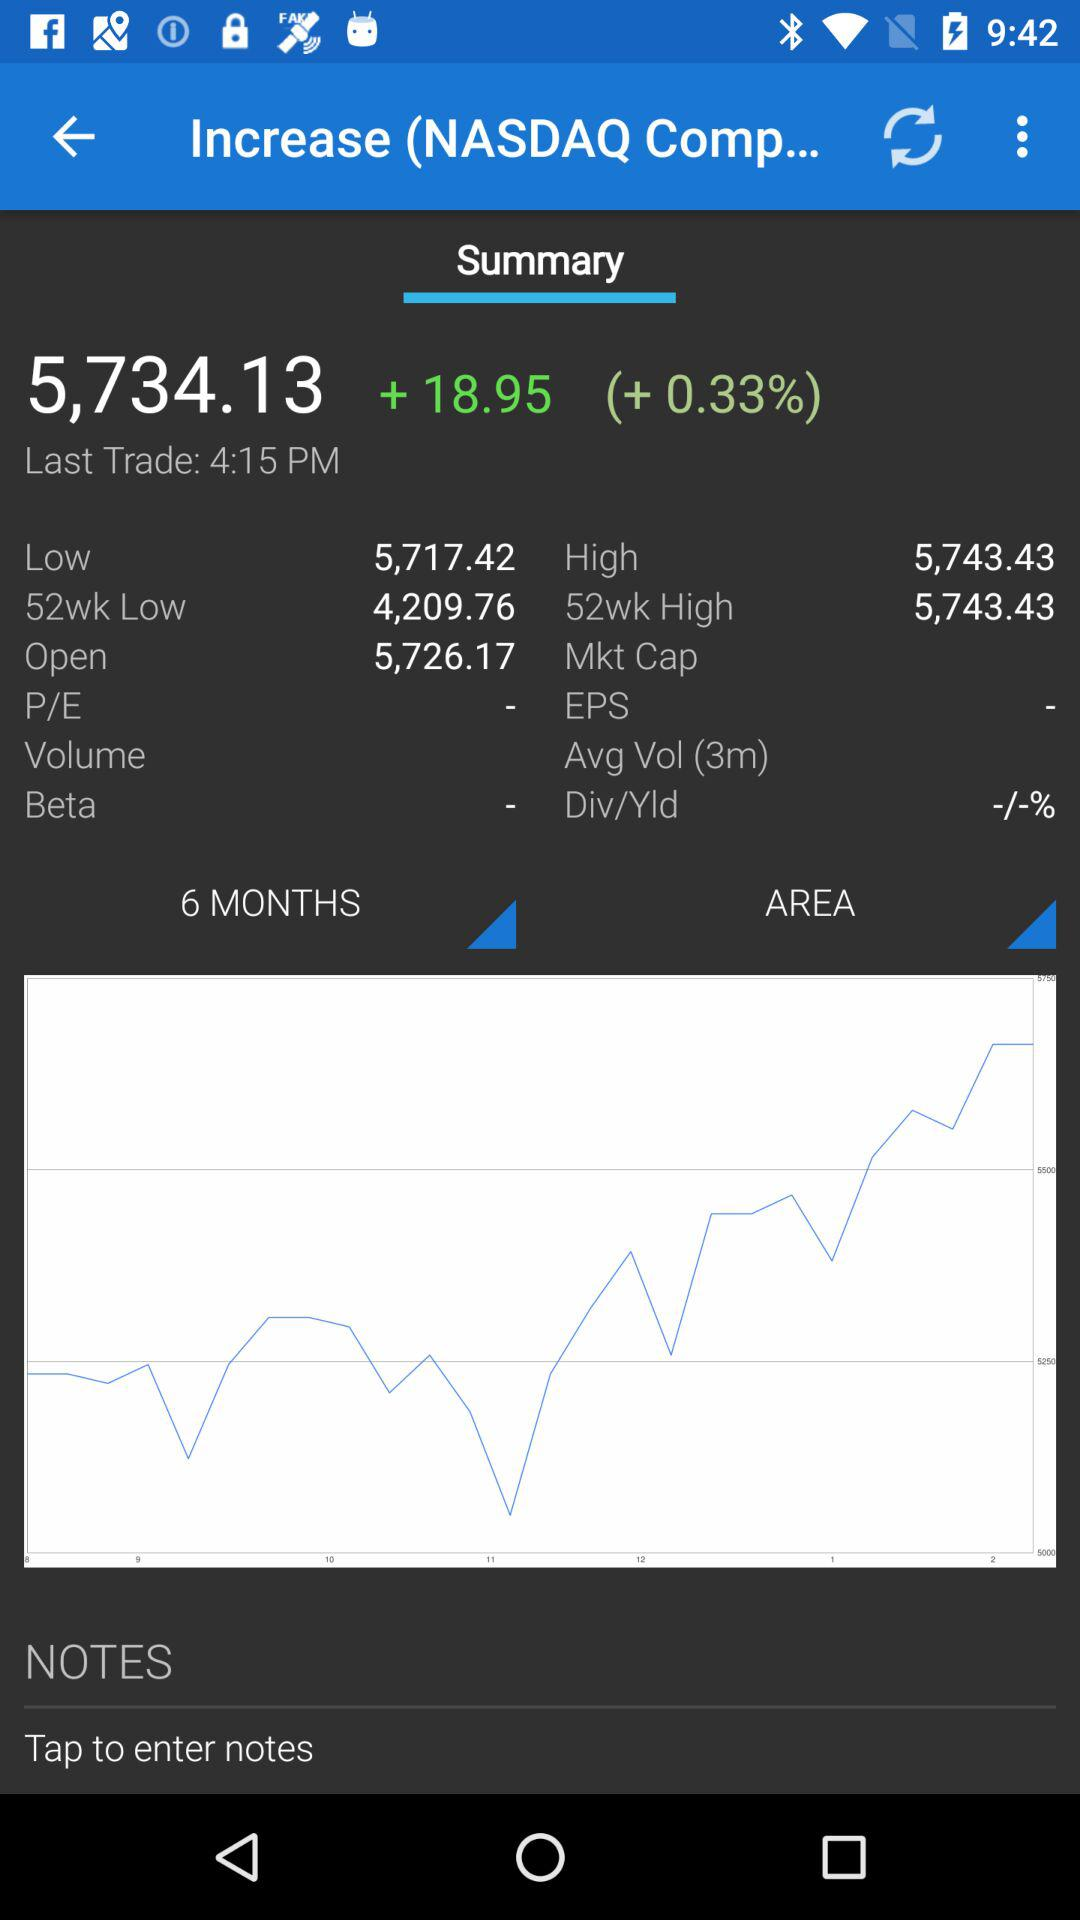What is the current price of the stock?
Answer the question using a single word or phrase. 5,734.13 